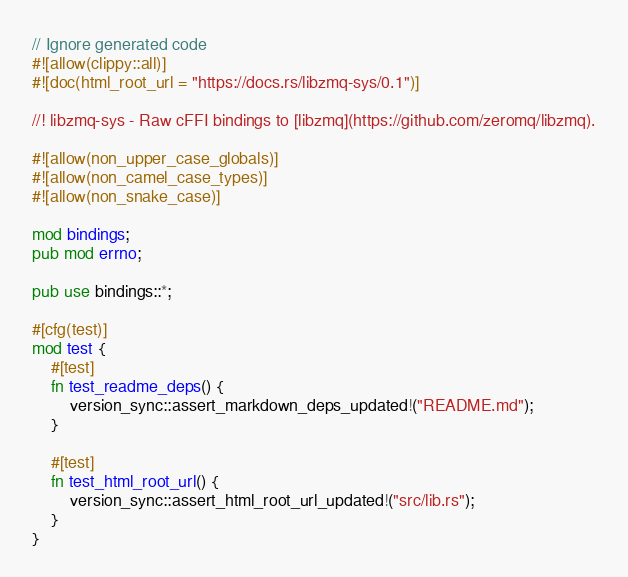Convert code to text. <code><loc_0><loc_0><loc_500><loc_500><_Rust_>// Ignore generated code
#![allow(clippy::all)]
#![doc(html_root_url = "https://docs.rs/libzmq-sys/0.1")]

//! libzmq-sys - Raw cFFI bindings to [libzmq](https://github.com/zeromq/libzmq).

#![allow(non_upper_case_globals)]
#![allow(non_camel_case_types)]
#![allow(non_snake_case)]

mod bindings;
pub mod errno;

pub use bindings::*;

#[cfg(test)]
mod test {
    #[test]
    fn test_readme_deps() {
        version_sync::assert_markdown_deps_updated!("README.md");
    }

    #[test]
    fn test_html_root_url() {
        version_sync::assert_html_root_url_updated!("src/lib.rs");
    }
}
</code> 